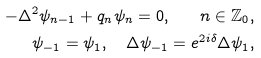Convert formula to latex. <formula><loc_0><loc_0><loc_500><loc_500>- \Delta ^ { 2 } \psi _ { n - 1 } + q _ { n } \psi _ { n } = 0 , \quad n \in \mathbb { Z } _ { 0 } , \\ \psi _ { - 1 } = \psi _ { 1 } , \quad \Delta \psi _ { - 1 } = e ^ { 2 i \delta } \Delta \psi _ { 1 } ,</formula> 